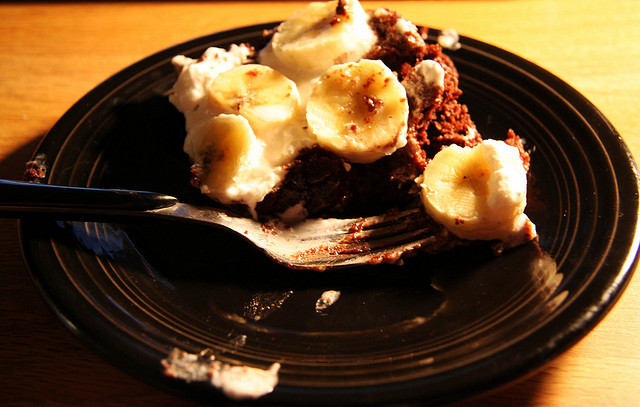Can you comment on the portion size of the dessert? The portion size appears to be suitable for one person, perfect for a satisfying dessert without being overly indulgent. 